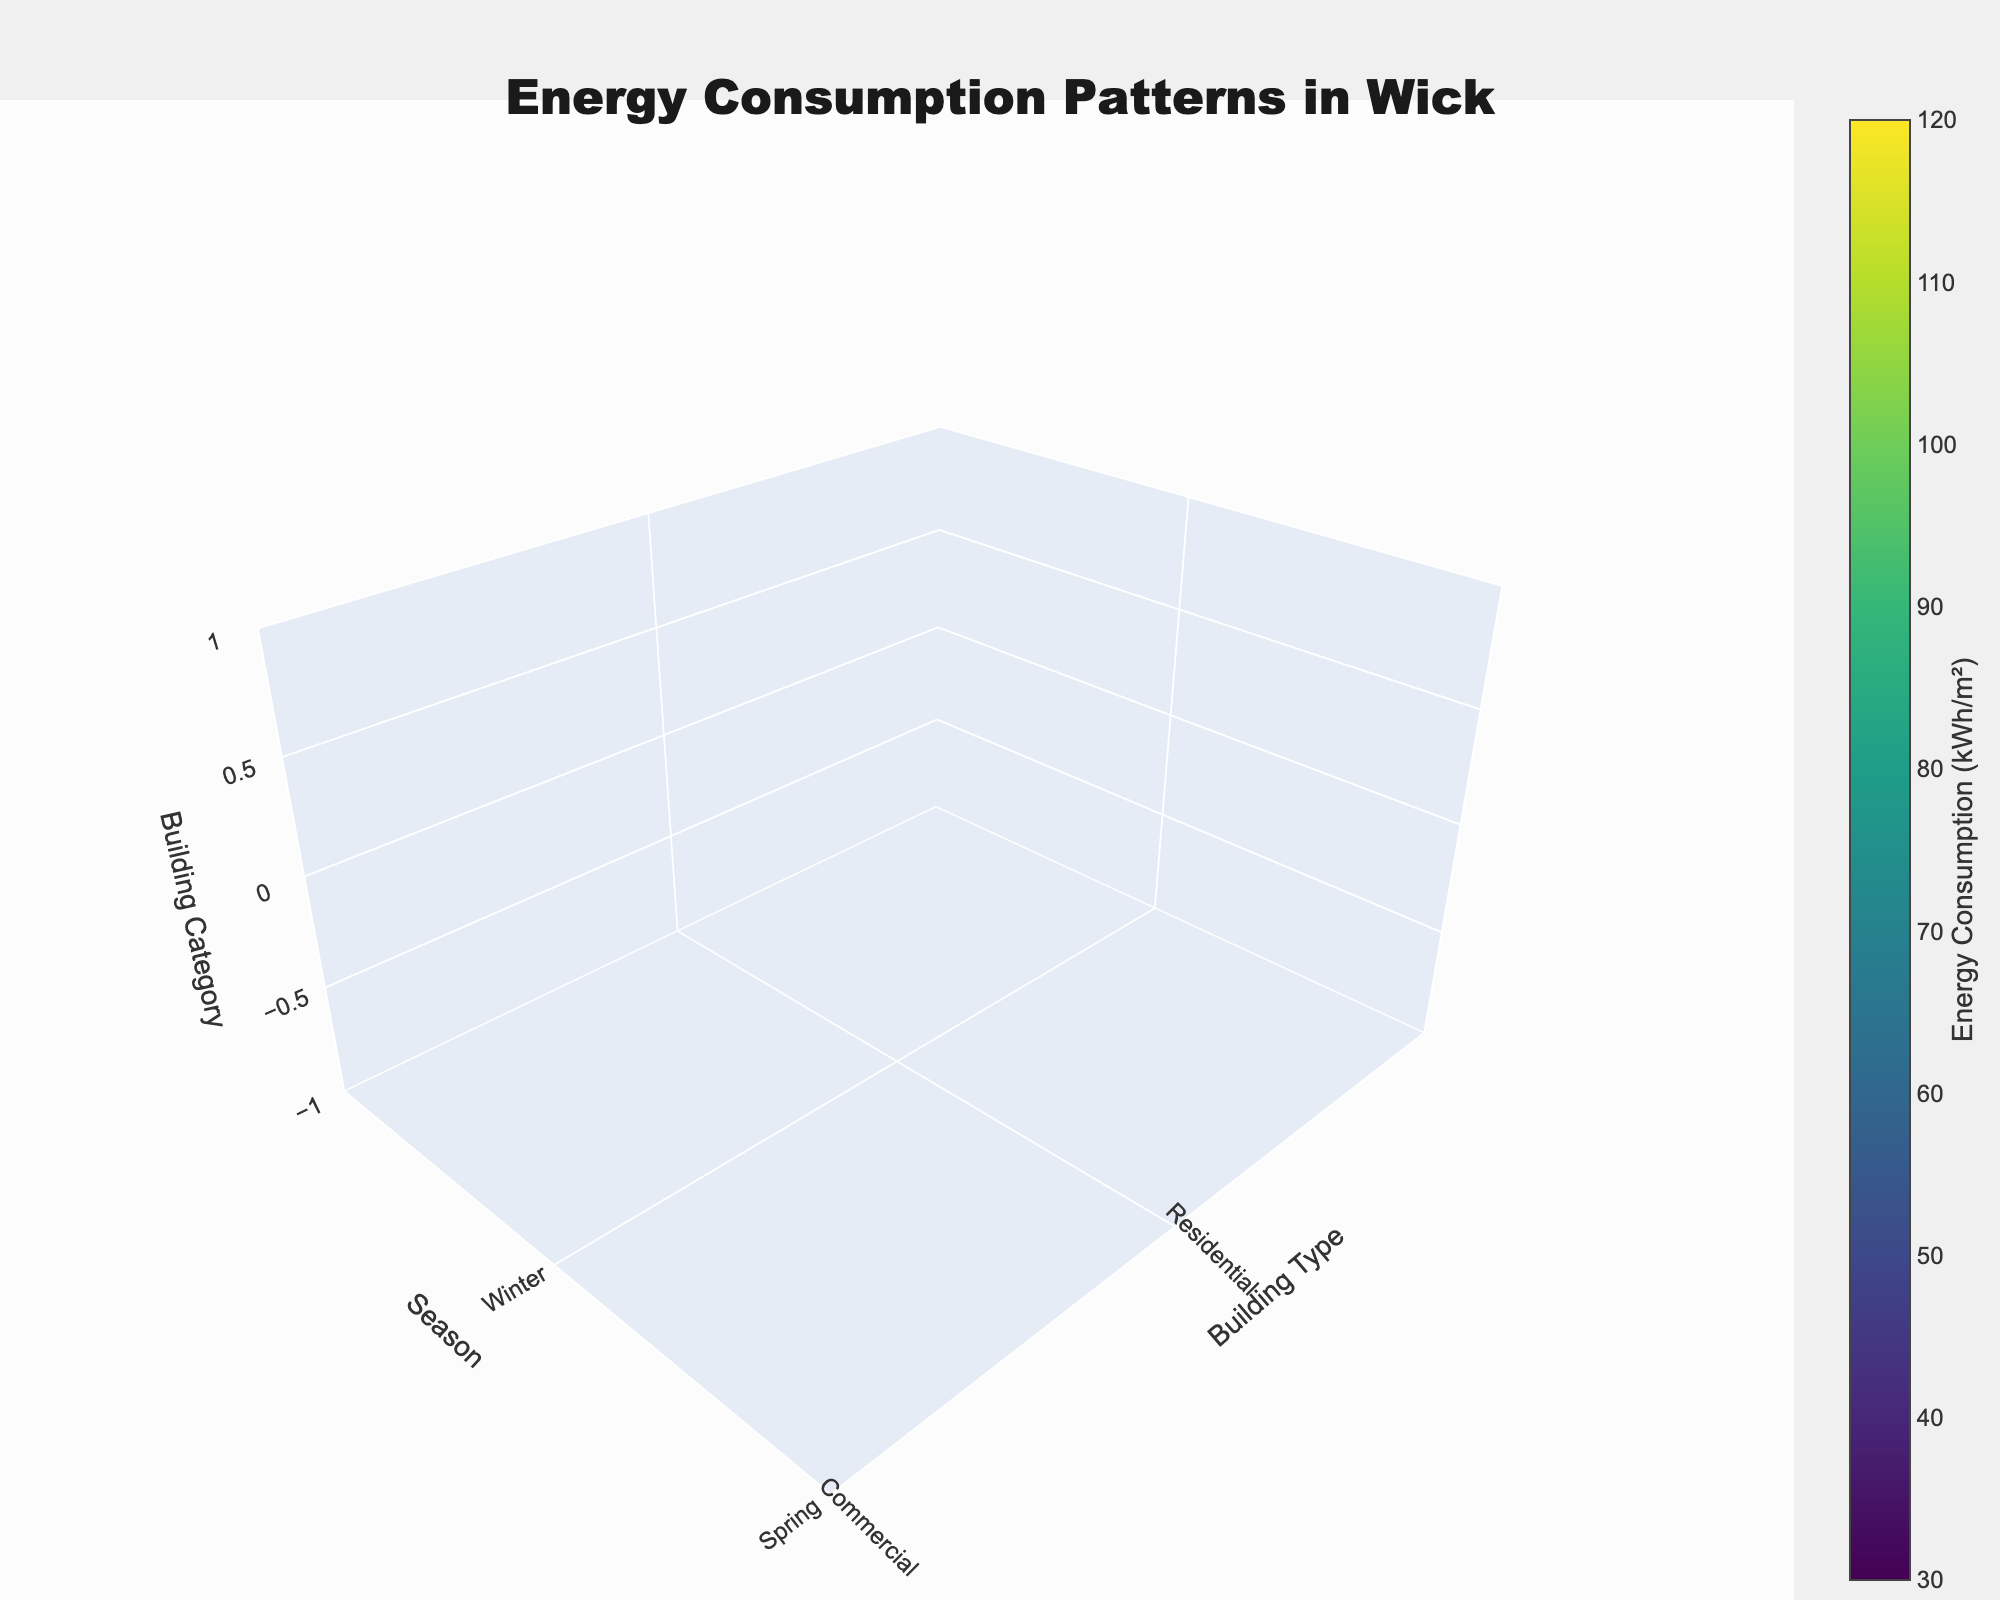What's the title of the figure? The title of the figure is prominently displayed at the top of the plot.
Answer: Energy Consumption Patterns in Wick Which building type has the highest energy consumption during winter? Look at the "Winter" season and note the highest energy consumption value, which corresponds to the "Industrial" building type at 120 kWh/m².
Answer: Industrial How does residential energy consumption in summer compare to winter? Compare the value for "Residential" in "Summer" (30 kWh/m²) with that in "Winter" (65 kWh/m²). Subtract the smaller from the larger value to determine the difference.
Answer: It is lower by 35 kWh/m² In which season is energy consumption in healthcare facilities the lowest? Identify the lowest value for "Healthcare Facilities" across "Winter" (90 kWh/m²), "Spring" (75 kWh/m²), "Summer" (70 kWh/m²), and "Autumn" (80 kWh/m²).
Answer: Summer What is the average energy consumption of public buildings across all seasons? Sum the values for "Public Buildings" (75 + 55 + 40 + 60 = 230 kWh/m²) and divide by the number of seasons (4).
Answer: 57.5 kWh/m² Which season has the highest overall energy consumption across all building types? Sum the energy consumption for all building types in each season, and compare the totals. For "Winter": 65 + 80 + 120 + 75 + 70 + 90 = 500, "Spring": 45 + 60 + 100 + 55 + 50 + 75 = 385, "Summer": 30 + 55 + 90 + 40 + 25 + 70 = 310, "Autumn": 50 + 70 + 110 + 60 + 55 + 80 = 425. Compare these totals.
Answer: Winter Between commercial and schools, which building type sees higher variability in energy consumption across seasons? Calculate the range (max - min) of energy consumption for each. For "Commercial": (80 - 55 = 25) and for "Schools": (70 - 25 = 45). Compare the ranges.
Answer: Schools have higher variability How does the energy consumption trend from winter to autumn differ between industrial and residential buildings? Look at the values for "Industrial" (Winter: 120, Autumn: 110) and "Residential" (Winter: 65, Autumn: 50). Compare the overall trends from winter to autumn for each type.
Answer: Both decrease, but Industrial has a smaller reduction 